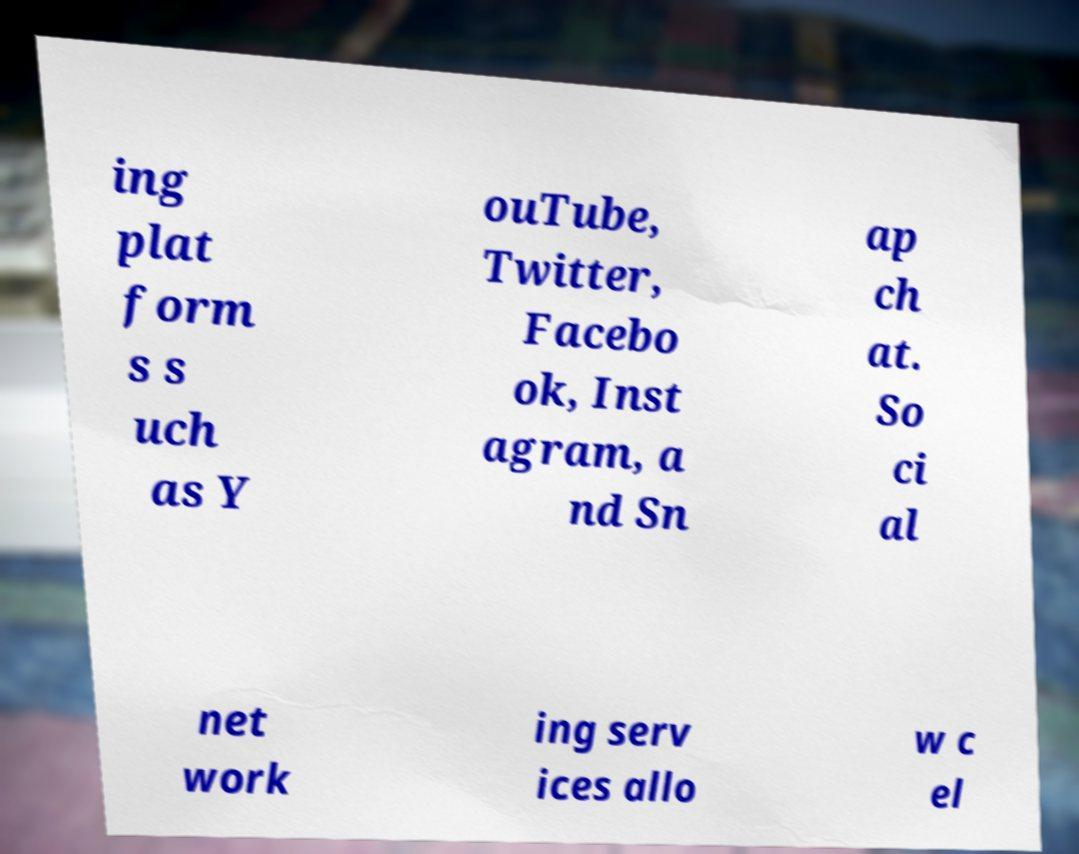What messages or text are displayed in this image? I need them in a readable, typed format. ing plat form s s uch as Y ouTube, Twitter, Facebo ok, Inst agram, a nd Sn ap ch at. So ci al net work ing serv ices allo w c el 